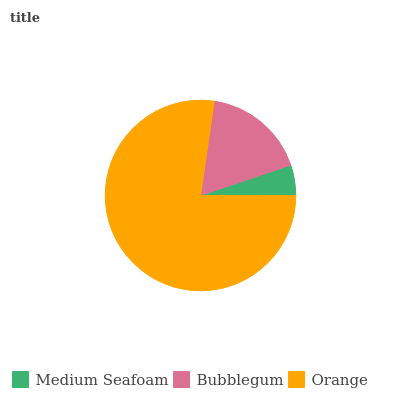Is Medium Seafoam the minimum?
Answer yes or no. Yes. Is Orange the maximum?
Answer yes or no. Yes. Is Bubblegum the minimum?
Answer yes or no. No. Is Bubblegum the maximum?
Answer yes or no. No. Is Bubblegum greater than Medium Seafoam?
Answer yes or no. Yes. Is Medium Seafoam less than Bubblegum?
Answer yes or no. Yes. Is Medium Seafoam greater than Bubblegum?
Answer yes or no. No. Is Bubblegum less than Medium Seafoam?
Answer yes or no. No. Is Bubblegum the high median?
Answer yes or no. Yes. Is Bubblegum the low median?
Answer yes or no. Yes. Is Medium Seafoam the high median?
Answer yes or no. No. Is Medium Seafoam the low median?
Answer yes or no. No. 